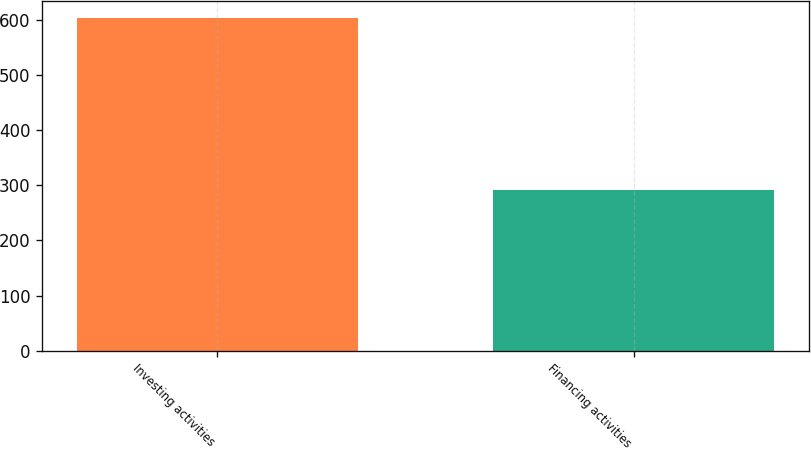<chart> <loc_0><loc_0><loc_500><loc_500><bar_chart><fcel>Investing activities<fcel>Financing activities<nl><fcel>604<fcel>292<nl></chart> 